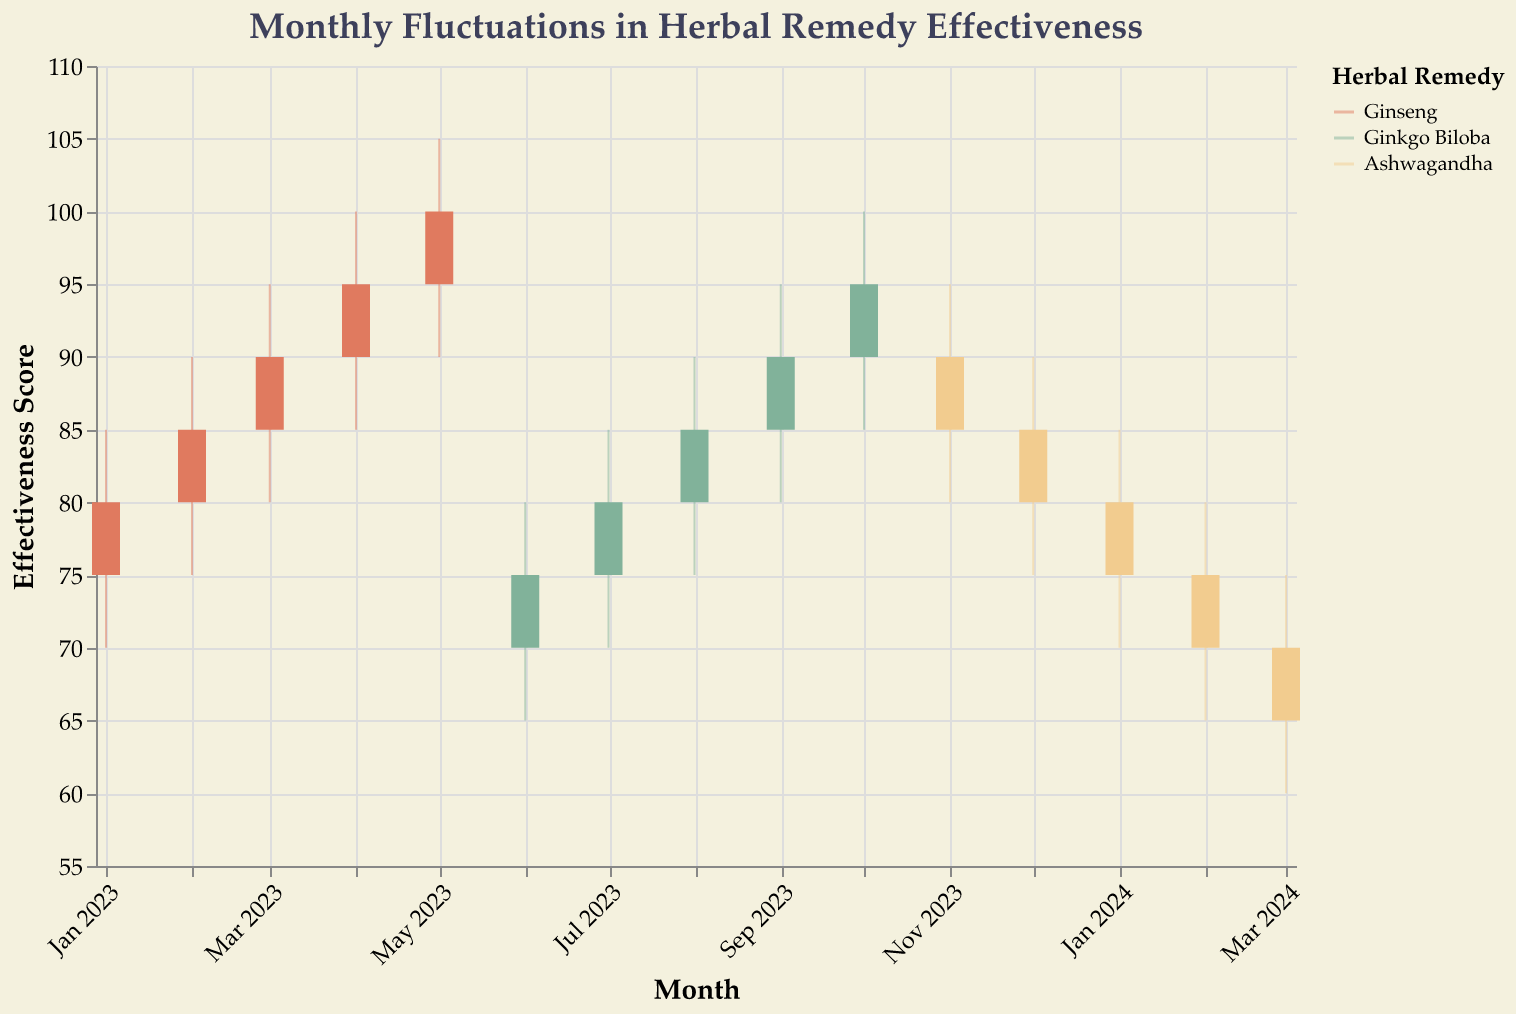What is the title of the plot? The title of the plot is displayed at the top and reads "Monthly Fluctuations in Herbal Remedy Effectiveness."
Answer: "Monthly Fluctuations in Herbal Remedy Effectiveness" How is the effectiveness score represented on the y-axis? The y-axis is labeled "Effectiveness Score" and it ranges from 55 to 110.
Answer: It ranges from 55 to 110 What is the color used to represent Ginkgo Biloba in the plot? Ginkgo Biloba is represented with a greenish color in the plot.
Answer: Greenish Which month shows the highest close value for Ginseng? The highest close value for Ginseng is observed in May 2023, where the close value is 100.
Answer: May 2023 Which herbal remedy has a low effectiveness score trend from December 2023 to March 2024? Ashwagandha shows a decreasing trend in effectiveness from December 2023 to March 2024.
Answer: Ashwagandha What is the difference in the high values of Ginkgo Biloba between June 2023 and October 2023? In June 2023, the high value for Ginkgo Biloba is 80, and in October 2023, it is 100. The difference is 100 - 80 = 20.
Answer: 20 Which herbal remedy experiences the most volatility in June 2023 based on the candlestick plot? Volatility is measured by the difference between the high and low values. In June 2023, Ginkgo Biloba has a high of 80 and a low of 65, giving a volatility of 80 - 65 = 15.
Answer: Ginkgo Biloba Compare the effectiveness scores for Ginseng in January 2023 and February 2023. Which month had a higher increase in its close value compared to its opening value? In January 2023, Ginseng's close value is 80 while its open value is 75, an increase of 5. In February 2023, the close value is 85 and the open value is 80, an increase of 5. Both months have the same increase.
Answer: Both months have the same increase What is the overall trend in the effectiveness score of Ashwagandha from November 2023 to March 2024? From November 2023 to March 2024, the effectiveness score of Ashwagandha shows a decreasing trend.
Answer: Decreasing In which month does Ginkgo Biloba reach a higher close value than any month for Ashwagandha? Ginkgo Biloba's close value reaches 95 in October 2023, which is higher than any close value reached by Ashwagandha.
Answer: October 2023 